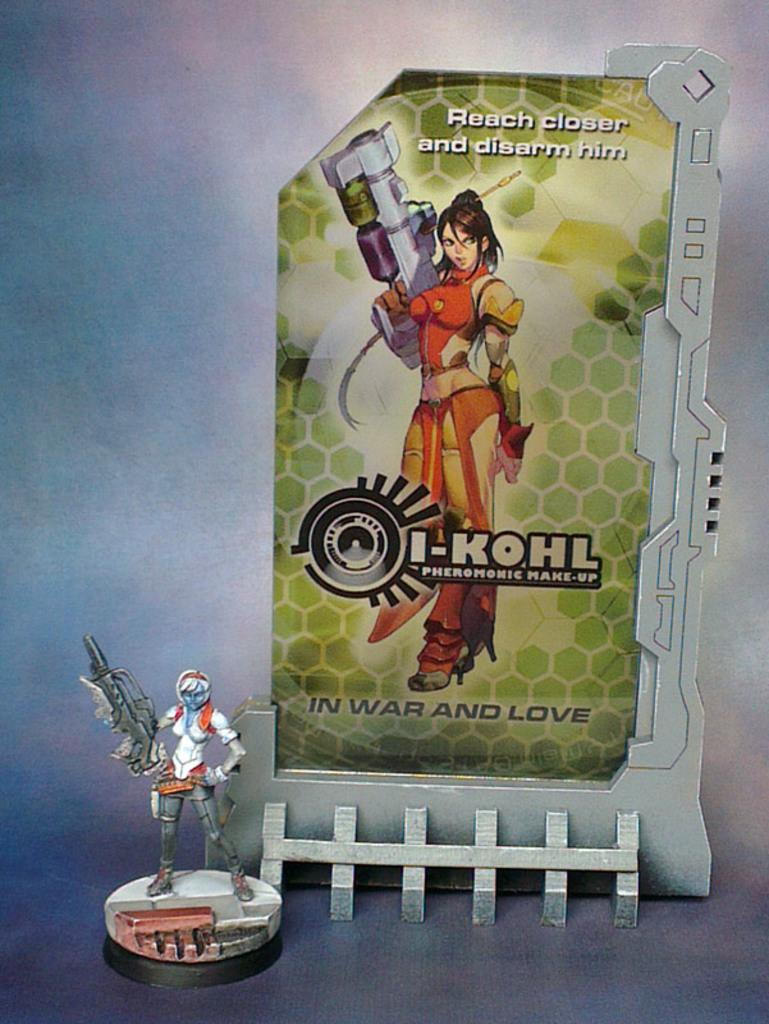What type of image is present in the center of the image? There is a cartoon image of a woman in the image. What other object can be seen in the image? There is a toy in the image. What is written at the top of the image? There is written text at the top of the image. How many cows are visible in the image? There are no cows present in the image. What type of zipper is featured on the woman's clothing in the image? There is no zipper visible on the woman's clothing in the image, as it is a cartoon image. 